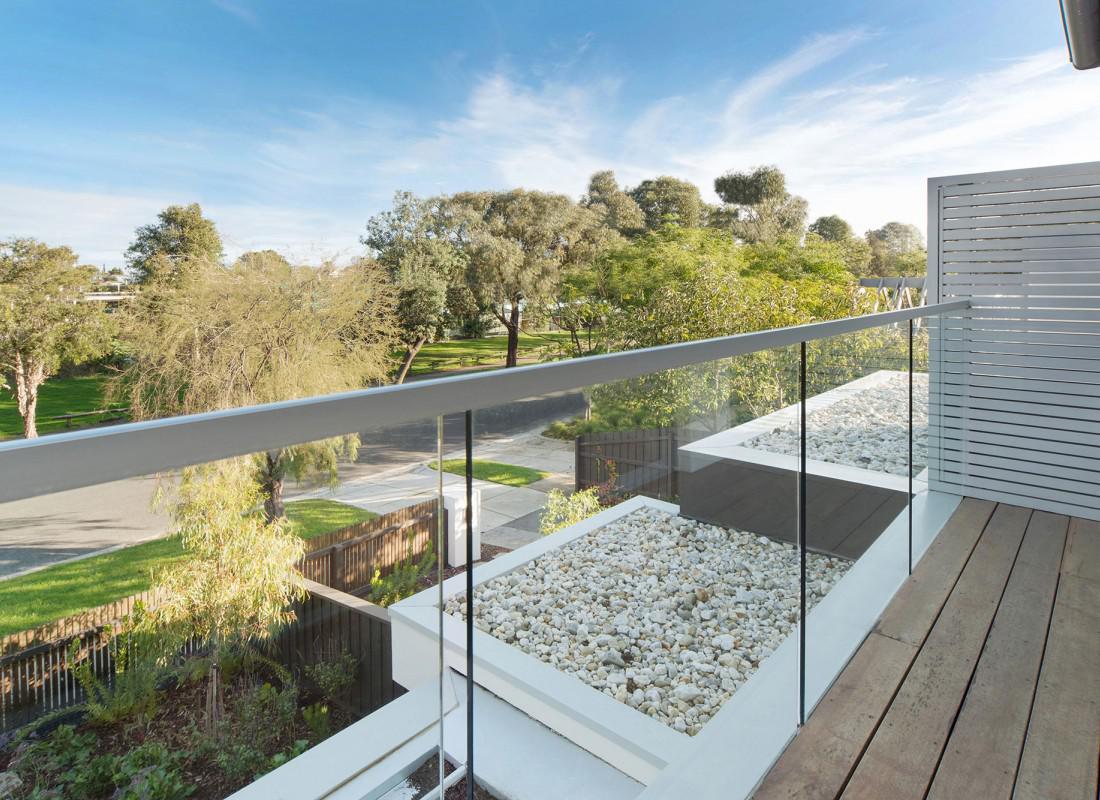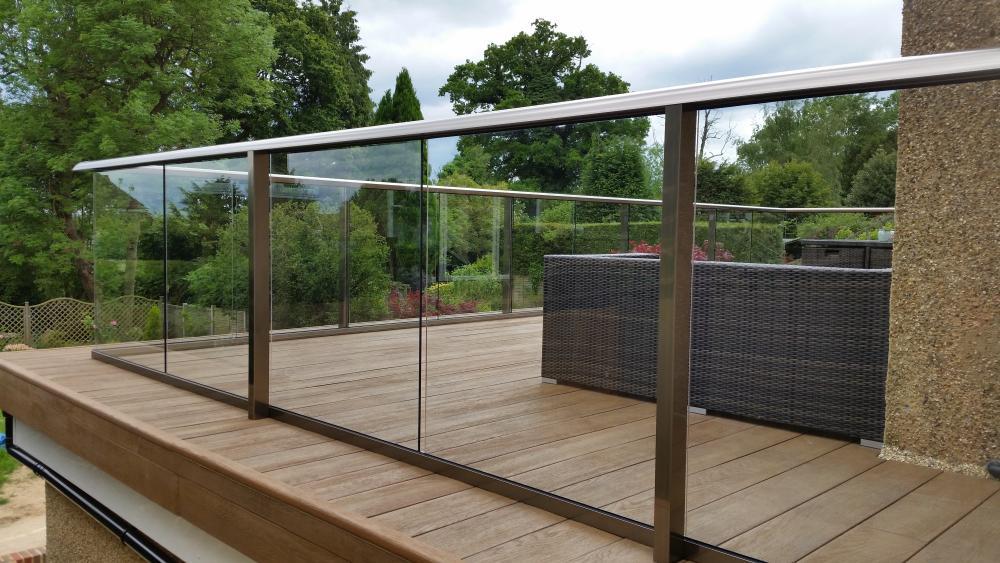The first image is the image on the left, the second image is the image on the right. For the images shown, is this caption "Both images are outside." true? Answer yes or no. Yes. The first image is the image on the left, the second image is the image on the right. For the images displayed, is the sentence "Each image features a glass-paneled balcony alongside a deck with plank boards, overlooking similar scenery." factually correct? Answer yes or no. Yes. 